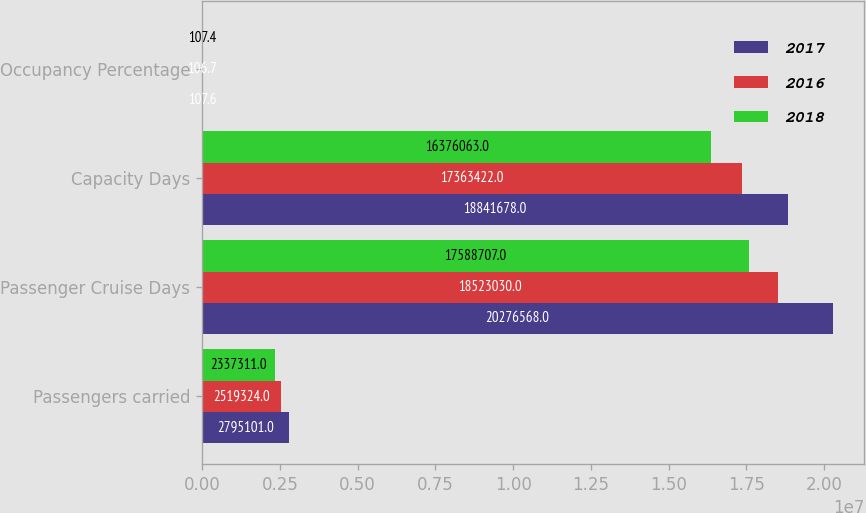<chart> <loc_0><loc_0><loc_500><loc_500><stacked_bar_chart><ecel><fcel>Passengers carried<fcel>Passenger Cruise Days<fcel>Capacity Days<fcel>Occupancy Percentage<nl><fcel>2017<fcel>2.7951e+06<fcel>2.02766e+07<fcel>1.88417e+07<fcel>107.6<nl><fcel>2016<fcel>2.51932e+06<fcel>1.8523e+07<fcel>1.73634e+07<fcel>106.7<nl><fcel>2018<fcel>2.33731e+06<fcel>1.75887e+07<fcel>1.63761e+07<fcel>107.4<nl></chart> 